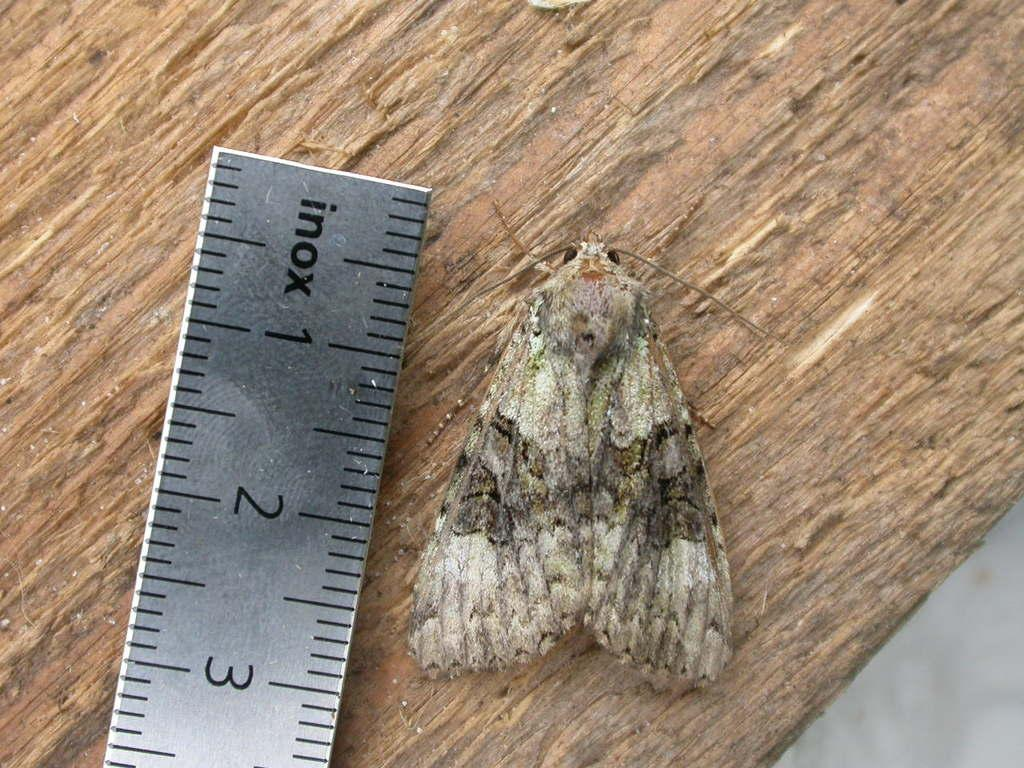Provide a one-sentence caption for the provided image. A moth that is being measured at 2 and 4/5 inches long. 